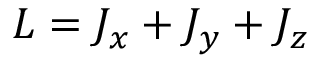<formula> <loc_0><loc_0><loc_500><loc_500>L = J _ { x } + J _ { y } + J _ { z }</formula> 